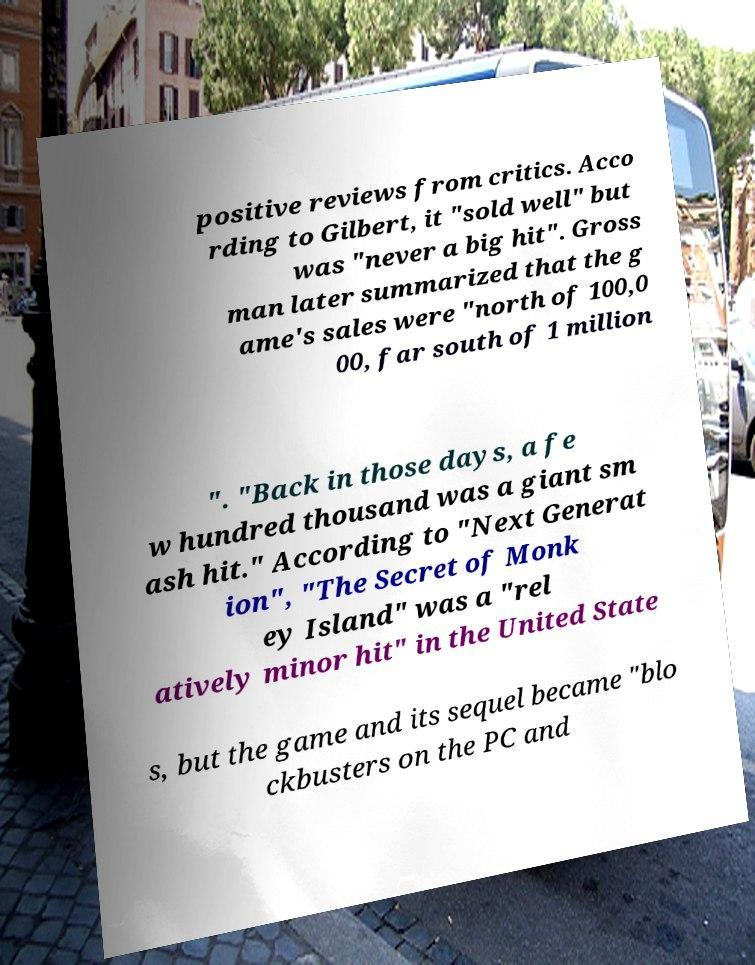Could you assist in decoding the text presented in this image and type it out clearly? positive reviews from critics. Acco rding to Gilbert, it "sold well" but was "never a big hit". Gross man later summarized that the g ame's sales were "north of 100,0 00, far south of 1 million ". "Back in those days, a fe w hundred thousand was a giant sm ash hit." According to "Next Generat ion", "The Secret of Monk ey Island" was a "rel atively minor hit" in the United State s, but the game and its sequel became "blo ckbusters on the PC and 